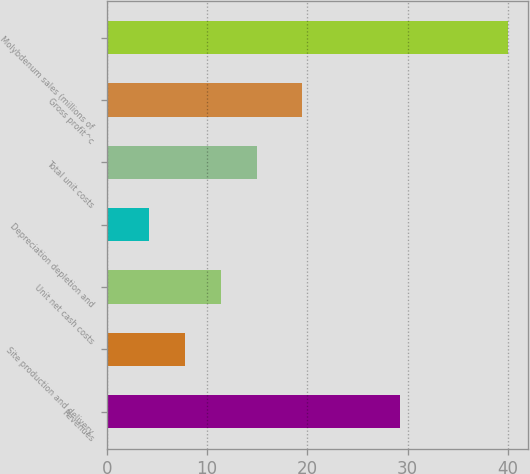Convert chart to OTSL. <chart><loc_0><loc_0><loc_500><loc_500><bar_chart><fcel>Revenues<fcel>Site production and delivery<fcel>Unit net cash costs<fcel>Depreciation depletion and<fcel>Total unit costs<fcel>Gross profit^c<fcel>Molybdenum sales (millions of<nl><fcel>29.27<fcel>7.83<fcel>11.41<fcel>4.25<fcel>14.98<fcel>19.48<fcel>40<nl></chart> 